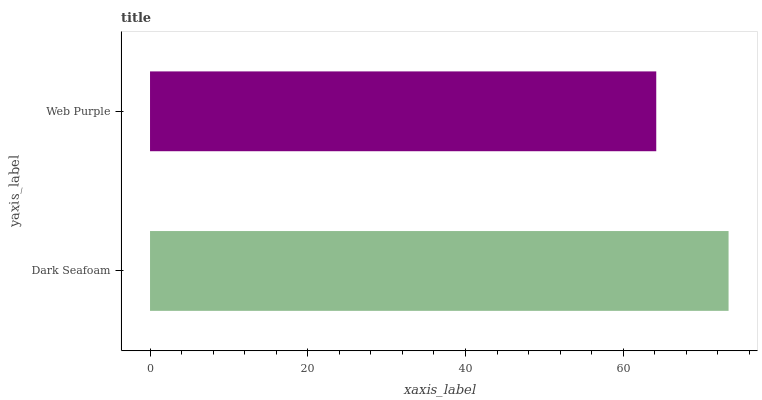Is Web Purple the minimum?
Answer yes or no. Yes. Is Dark Seafoam the maximum?
Answer yes or no. Yes. Is Web Purple the maximum?
Answer yes or no. No. Is Dark Seafoam greater than Web Purple?
Answer yes or no. Yes. Is Web Purple less than Dark Seafoam?
Answer yes or no. Yes. Is Web Purple greater than Dark Seafoam?
Answer yes or no. No. Is Dark Seafoam less than Web Purple?
Answer yes or no. No. Is Dark Seafoam the high median?
Answer yes or no. Yes. Is Web Purple the low median?
Answer yes or no. Yes. Is Web Purple the high median?
Answer yes or no. No. Is Dark Seafoam the low median?
Answer yes or no. No. 